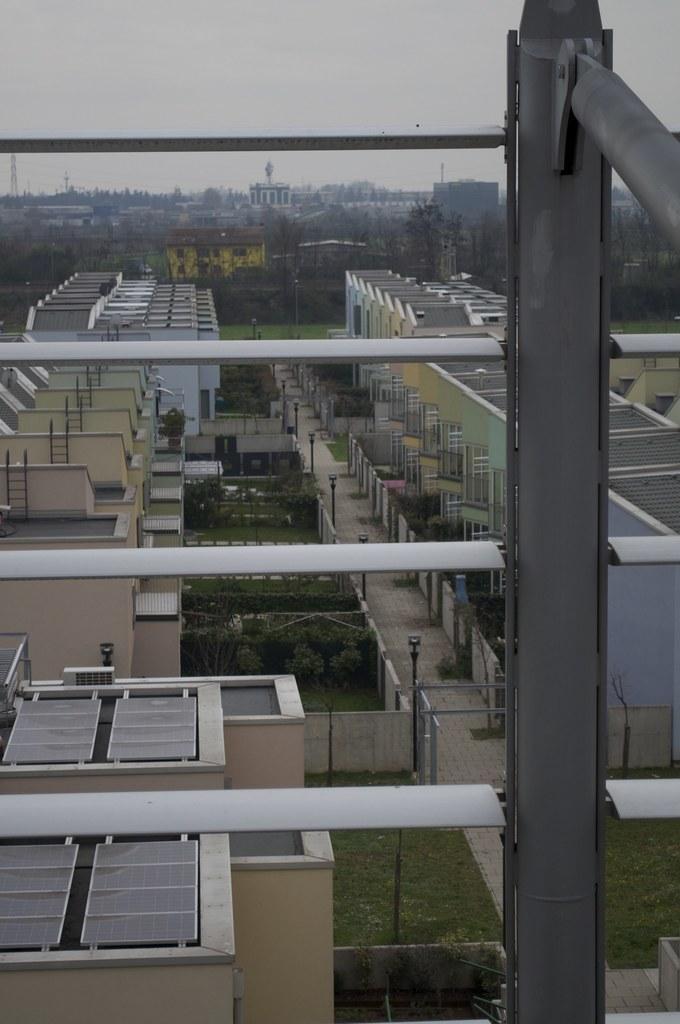Please provide a concise description of this image. In the picture I can see buildings, fence, poles, the grass and some other objects on the ground. In the background I can see trees and the sky. 